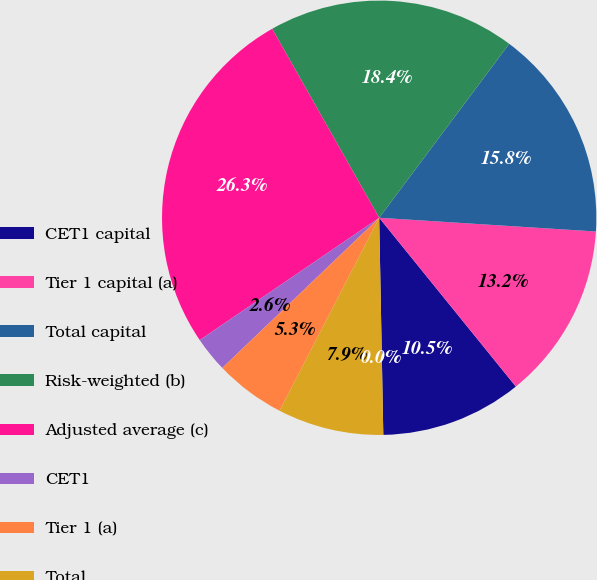Convert chart to OTSL. <chart><loc_0><loc_0><loc_500><loc_500><pie_chart><fcel>CET1 capital<fcel>Tier 1 capital (a)<fcel>Total capital<fcel>Risk-weighted (b)<fcel>Adjusted average (c)<fcel>CET1<fcel>Tier 1 (a)<fcel>Total<fcel>Tier 1 leverage (e)<nl><fcel>10.53%<fcel>13.16%<fcel>15.79%<fcel>18.42%<fcel>26.32%<fcel>2.63%<fcel>5.26%<fcel>7.89%<fcel>0.0%<nl></chart> 